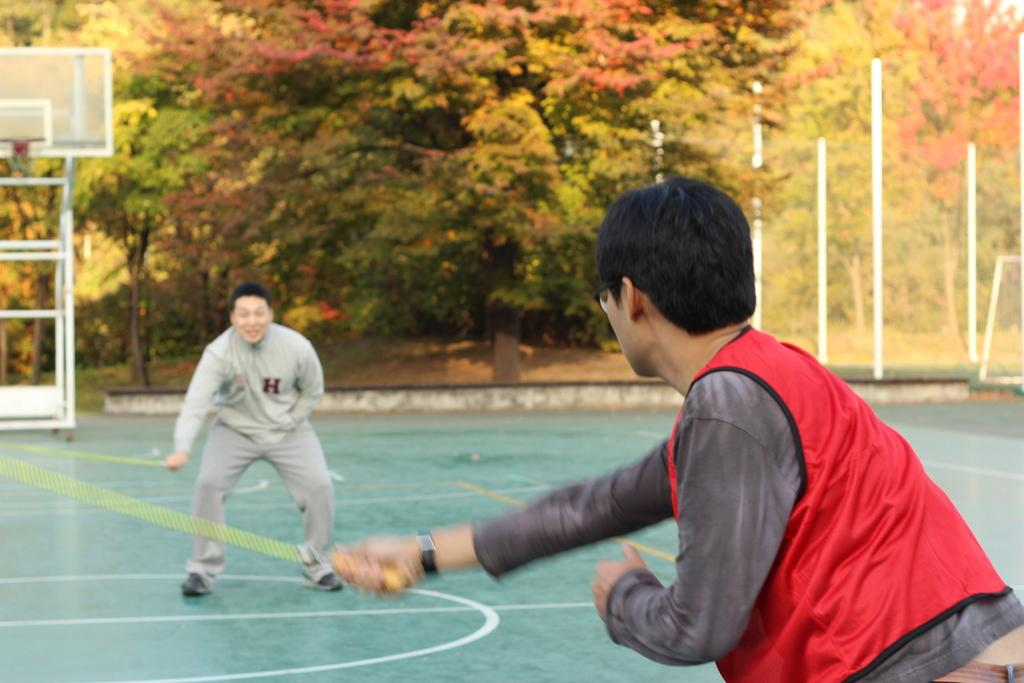How many people are in the image? There are two persons in the image. What are the persons doing in the image? The persons are standing and holding the handles of a skipping rope. What can be seen in the background of the image? There is a basketball net, poles, and trees in the background of the image. What type of pump is visible in the image, and how is it contributing to the wealth of the individuals in the image? There is no pump present in the image, and the wealth of the individuals cannot be determined from the image. 